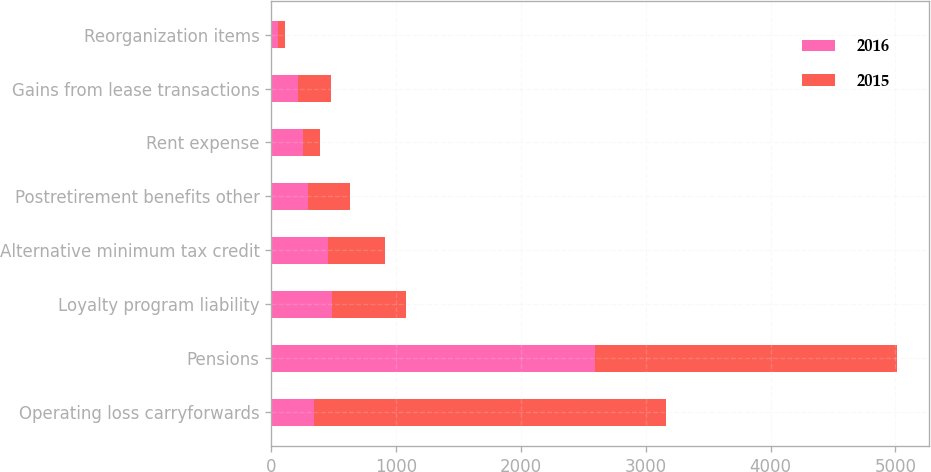Convert chart to OTSL. <chart><loc_0><loc_0><loc_500><loc_500><stacked_bar_chart><ecel><fcel>Operating loss carryforwards<fcel>Pensions<fcel>Loyalty program liability<fcel>Alternative minimum tax credit<fcel>Postretirement benefits other<fcel>Rent expense<fcel>Gains from lease transactions<fcel>Reorganization items<nl><fcel>2016<fcel>340<fcel>2595<fcel>485<fcel>456<fcel>291<fcel>256<fcel>213<fcel>53<nl><fcel>2015<fcel>2818<fcel>2420<fcel>590<fcel>458<fcel>340<fcel>134<fcel>261<fcel>57<nl></chart> 